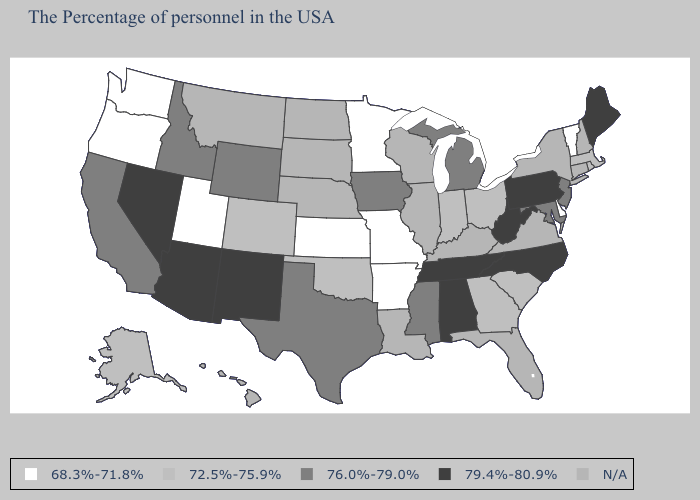What is the value of Alaska?
Concise answer only. 72.5%-75.9%. Name the states that have a value in the range 79.4%-80.9%?
Quick response, please. Maine, Pennsylvania, North Carolina, West Virginia, Alabama, Tennessee, New Mexico, Arizona, Nevada. What is the value of Rhode Island?
Concise answer only. 72.5%-75.9%. Does Maine have the highest value in the Northeast?
Keep it brief. Yes. What is the value of Georgia?
Write a very short answer. 72.5%-75.9%. Name the states that have a value in the range 76.0%-79.0%?
Be succinct. New Jersey, Maryland, Michigan, Mississippi, Iowa, Texas, Wyoming, Idaho, California. Is the legend a continuous bar?
Short answer required. No. What is the value of Montana?
Write a very short answer. N/A. Name the states that have a value in the range 68.3%-71.8%?
Concise answer only. Vermont, Delaware, Missouri, Arkansas, Minnesota, Kansas, Utah, Washington, Oregon. What is the value of Hawaii?
Be succinct. N/A. What is the lowest value in the USA?
Be succinct. 68.3%-71.8%. Name the states that have a value in the range 68.3%-71.8%?
Short answer required. Vermont, Delaware, Missouri, Arkansas, Minnesota, Kansas, Utah, Washington, Oregon. What is the value of New Hampshire?
Give a very brief answer. N/A. 